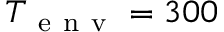<formula> <loc_0><loc_0><loc_500><loc_500>T _ { e n v } = 3 0 0</formula> 